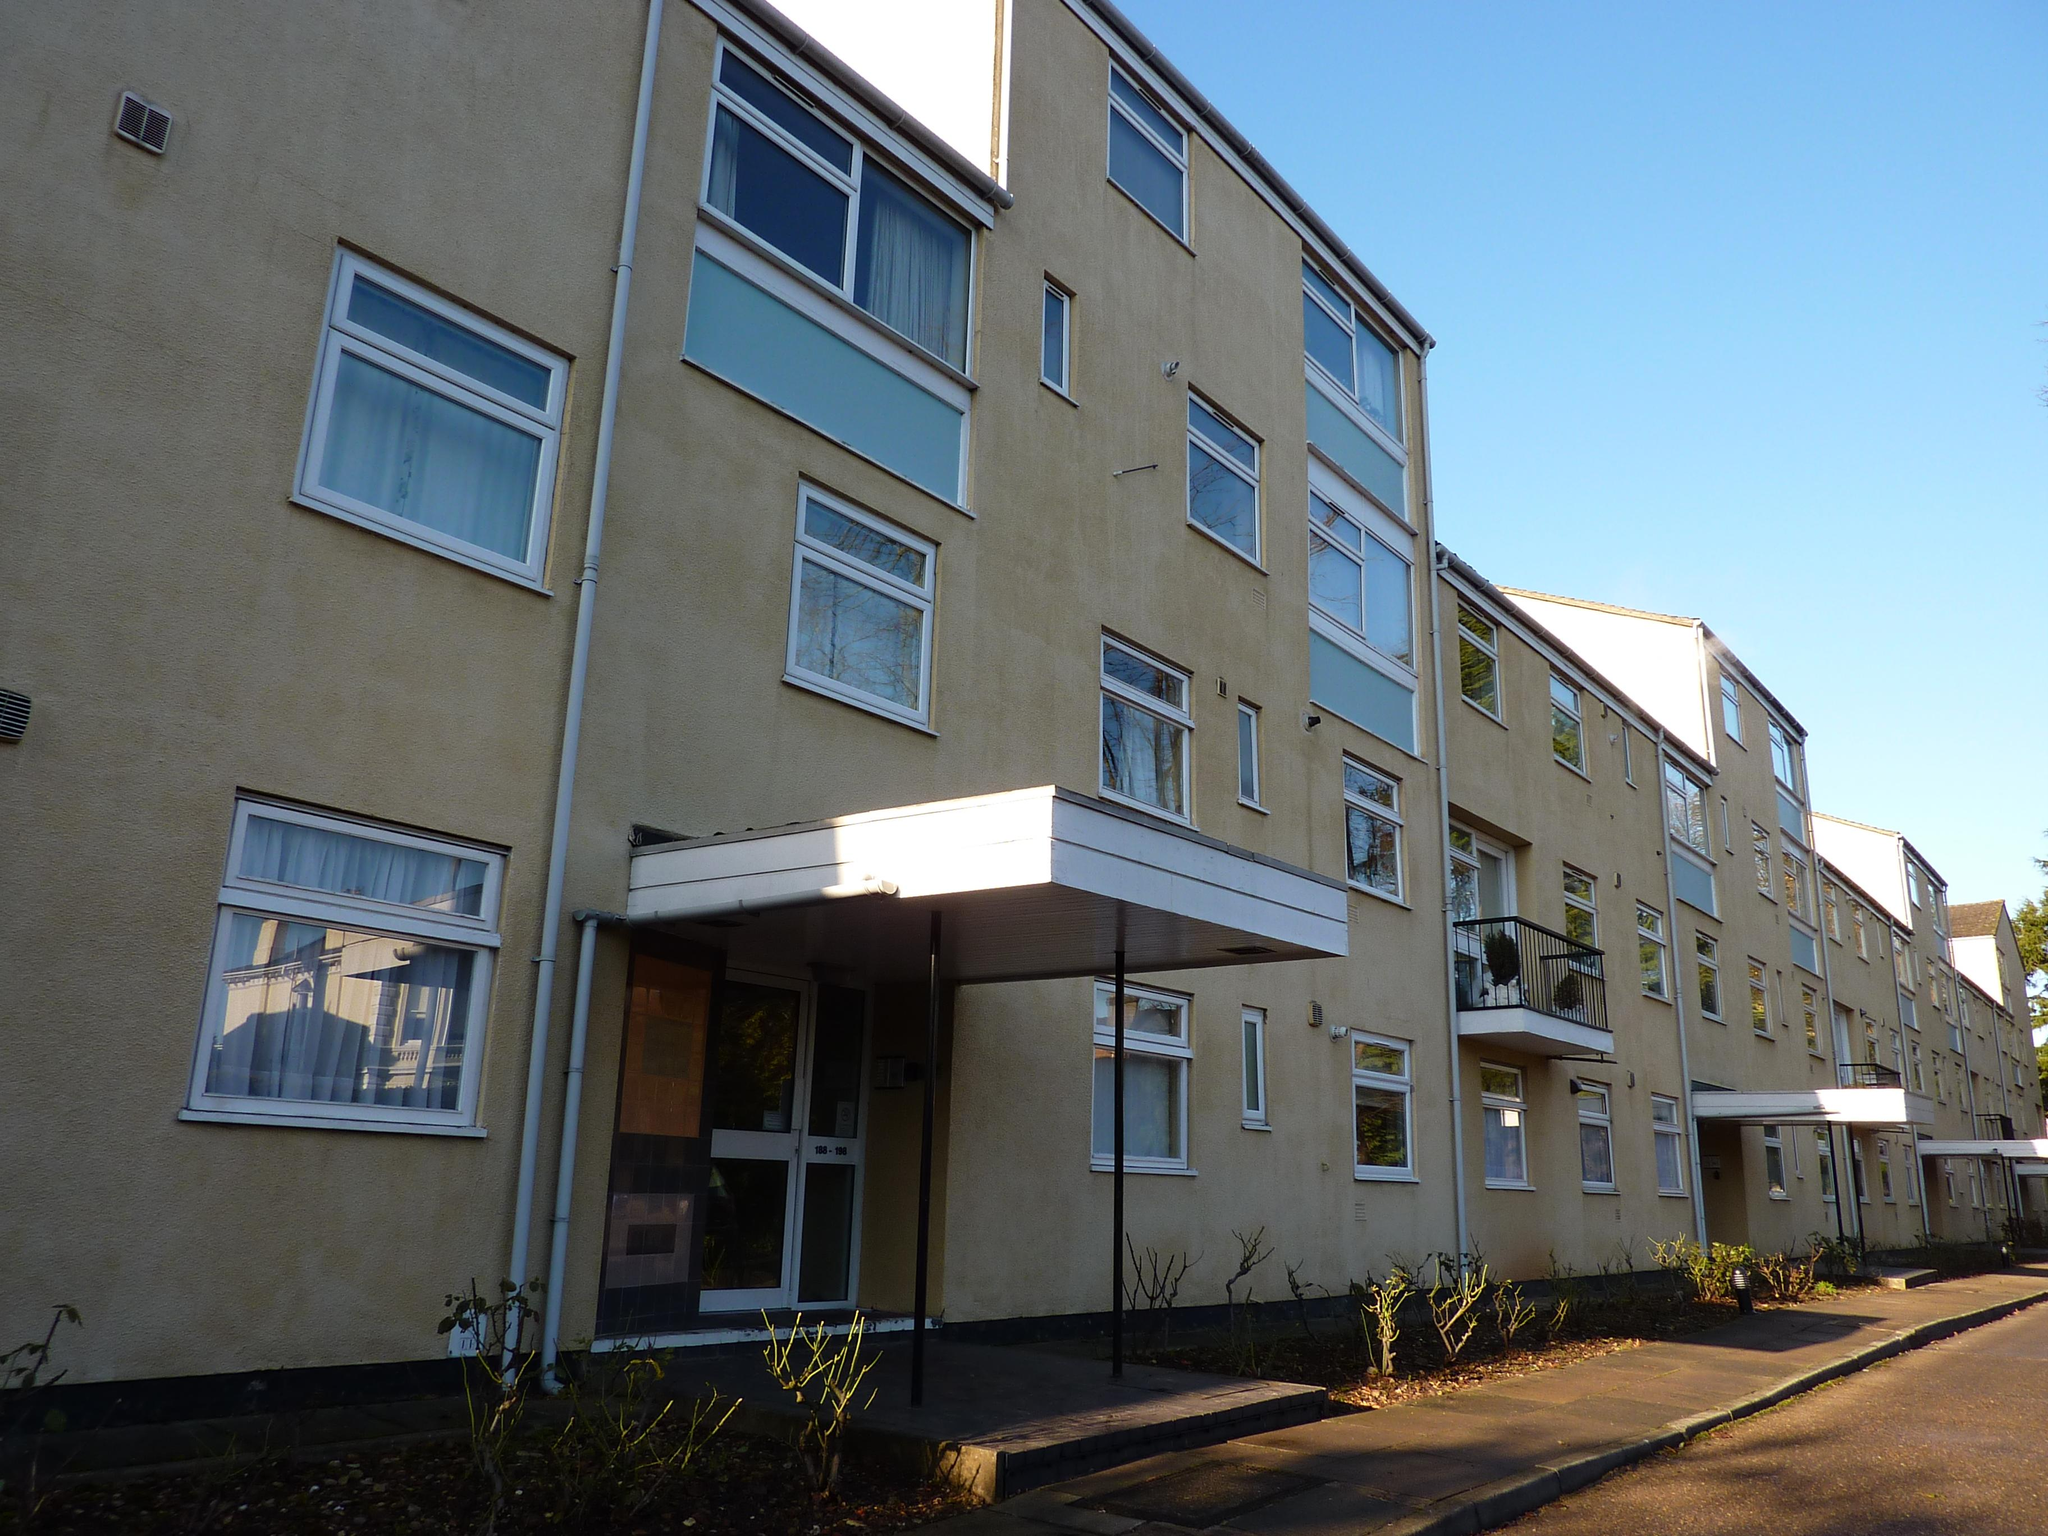What type of pathway is visible in the image? There is a road in the image. What other natural elements can be seen in the image? There are plants and a tree in the image. How many buildings are present in the image? There are multiple buildings in the image. What can be seen in the background of the image? The sky is visible in the background of the image. What is the duck's belief about the desire for more plants in the image? There is no duck present in the image, so it is not possible to determine its beliefs or desires about the plants. 